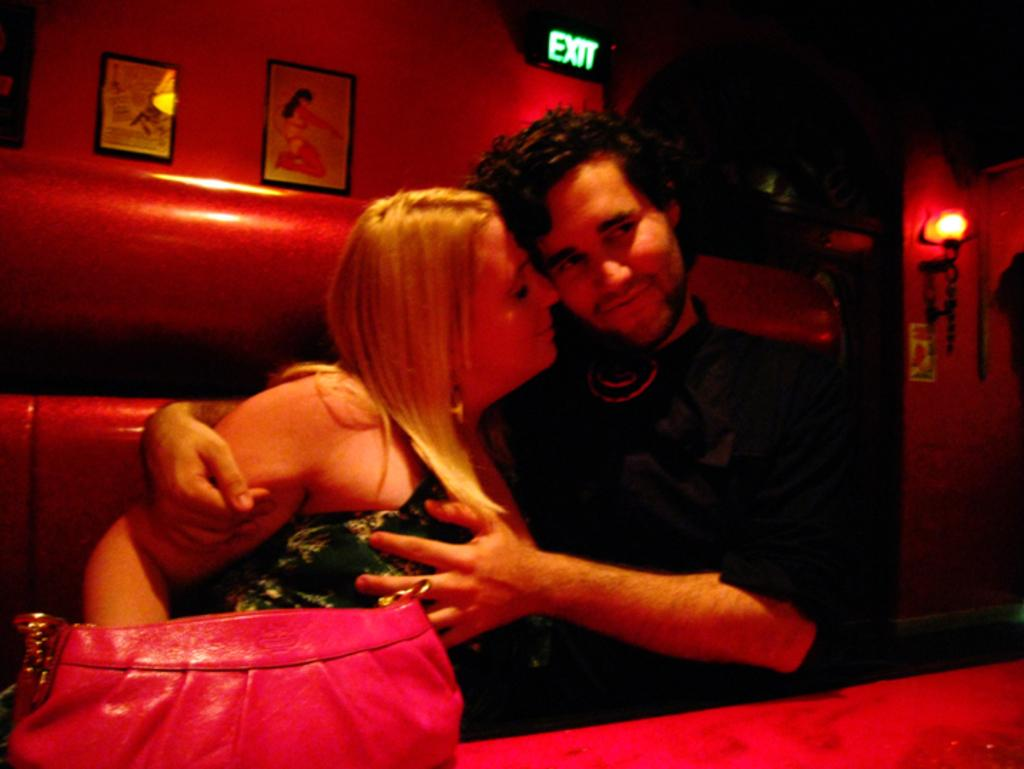How many people are seated on the sofa in the image? There are two people seated on the sofa in the image. What is located in front of the sofa? There is a bag in front of the sofa. What can be seen in the background of the image? There are wall paintings and light visible in the background. What book is the person on the left reading in the image? There is no book present in the image; the two people are seated on the sofa without any visible reading material. 